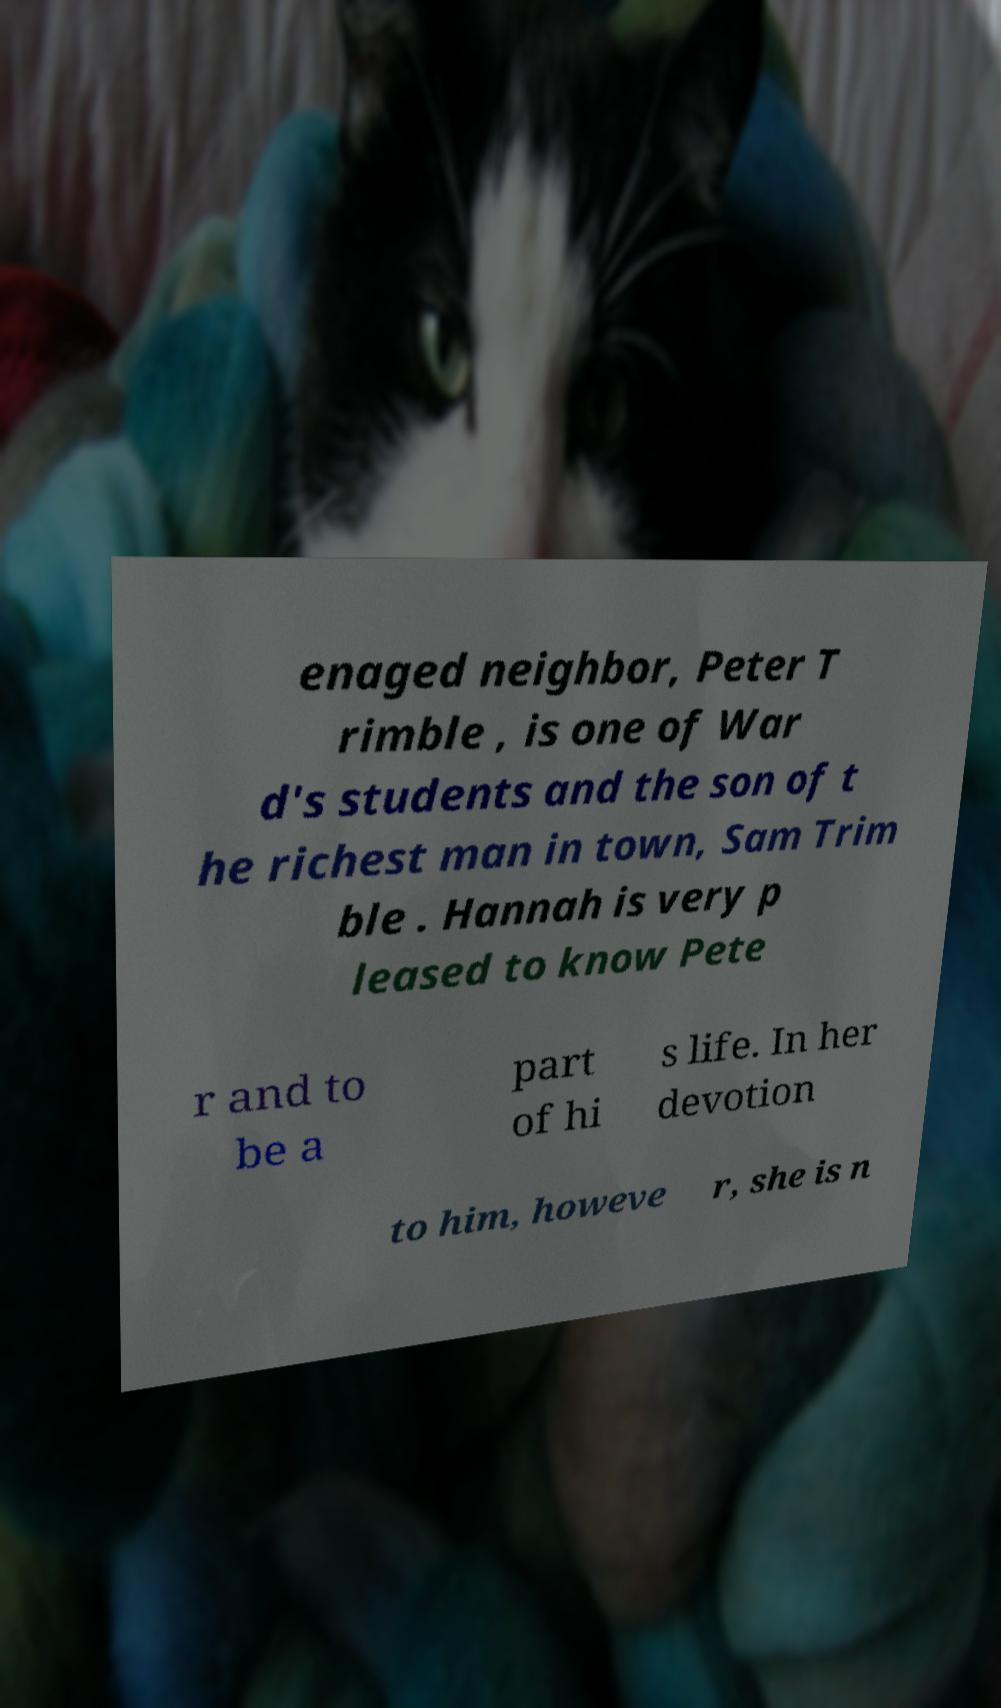What messages or text are displayed in this image? I need them in a readable, typed format. enaged neighbor, Peter T rimble , is one of War d's students and the son of t he richest man in town, Sam Trim ble . Hannah is very p leased to know Pete r and to be a part of hi s life. In her devotion to him, howeve r, she is n 